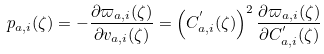Convert formula to latex. <formula><loc_0><loc_0><loc_500><loc_500>p _ { a , i } ( \zeta ) = - \frac { \partial \varpi _ { a , i } ( \zeta ) } { \partial v _ { a , i } ( \zeta ) } = \left ( C _ { a , i } ^ { ^ { \prime } } ( \zeta ) \right ) ^ { 2 } \frac { \partial \varpi _ { a , i } ( \zeta ) } { \partial C _ { a , i } ^ { ^ { \prime } } ( \zeta ) }</formula> 